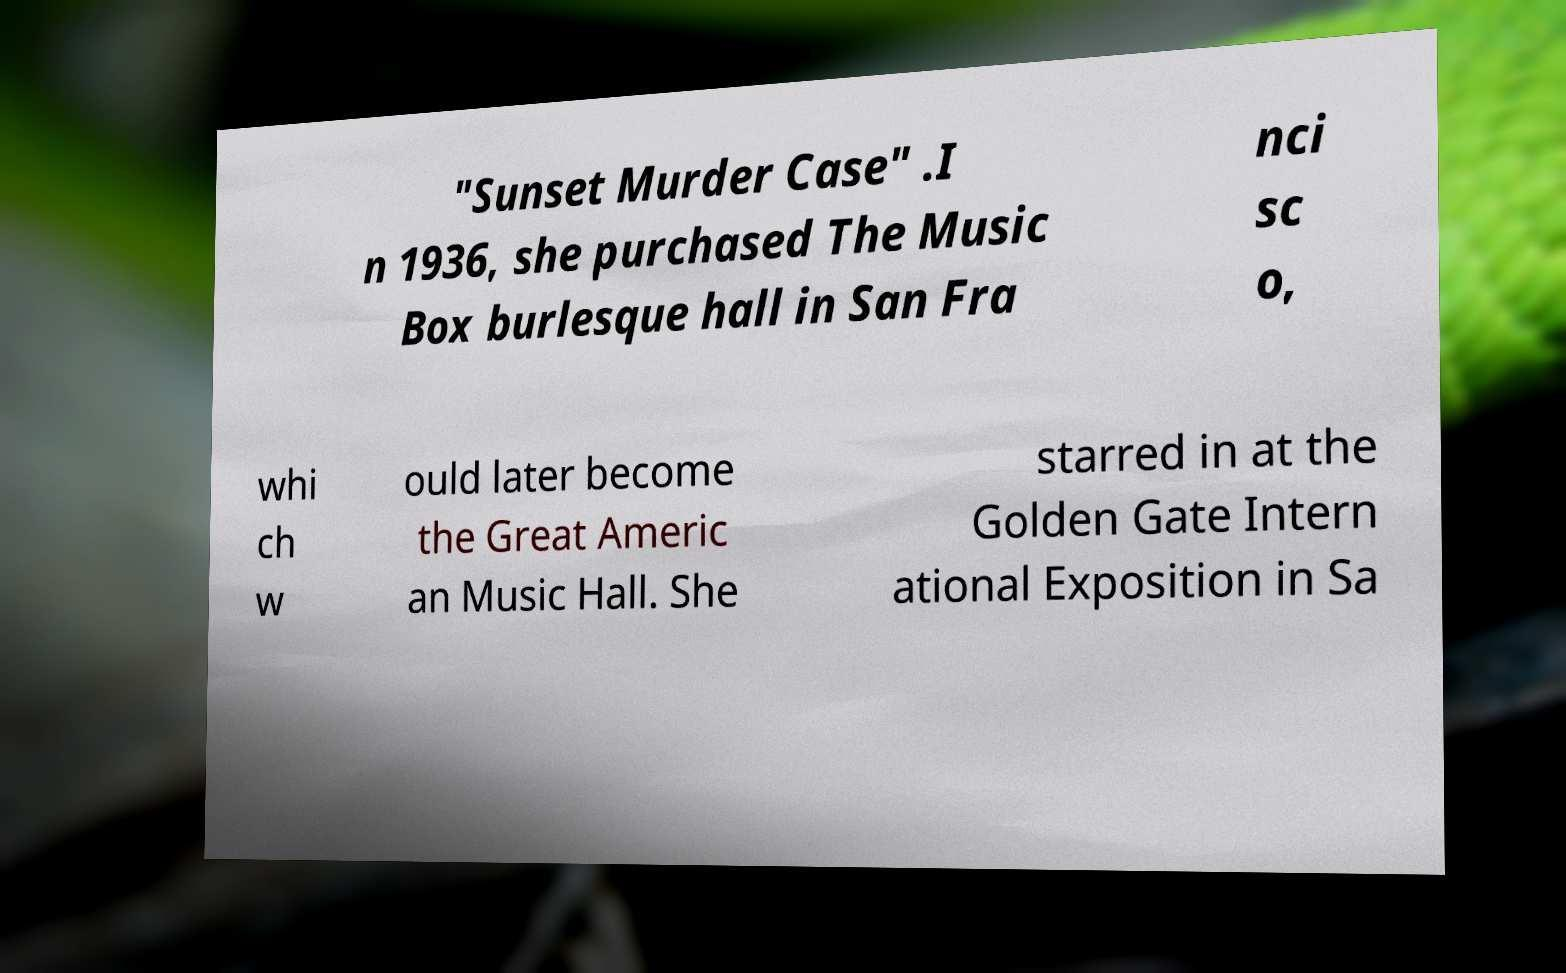Could you assist in decoding the text presented in this image and type it out clearly? "Sunset Murder Case" .I n 1936, she purchased The Music Box burlesque hall in San Fra nci sc o, whi ch w ould later become the Great Americ an Music Hall. She starred in at the Golden Gate Intern ational Exposition in Sa 